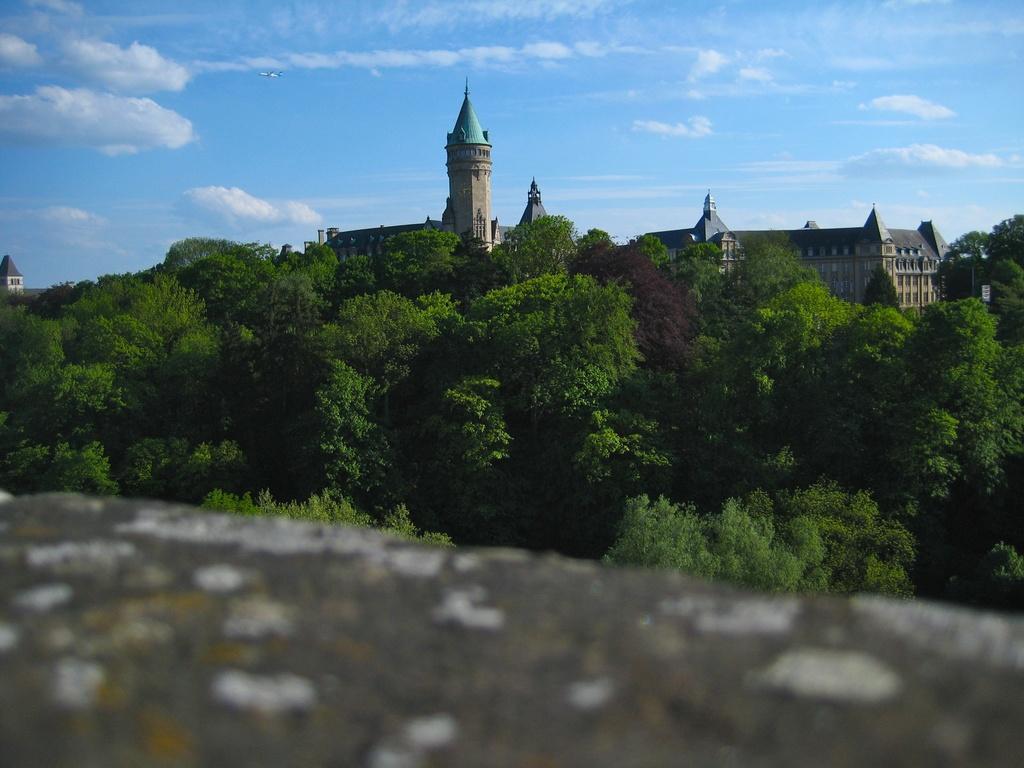Can you describe this image briefly? In this image we can see trees. In the back there are buildings. Also there is sky with clouds. At the bottom it is blurry. 